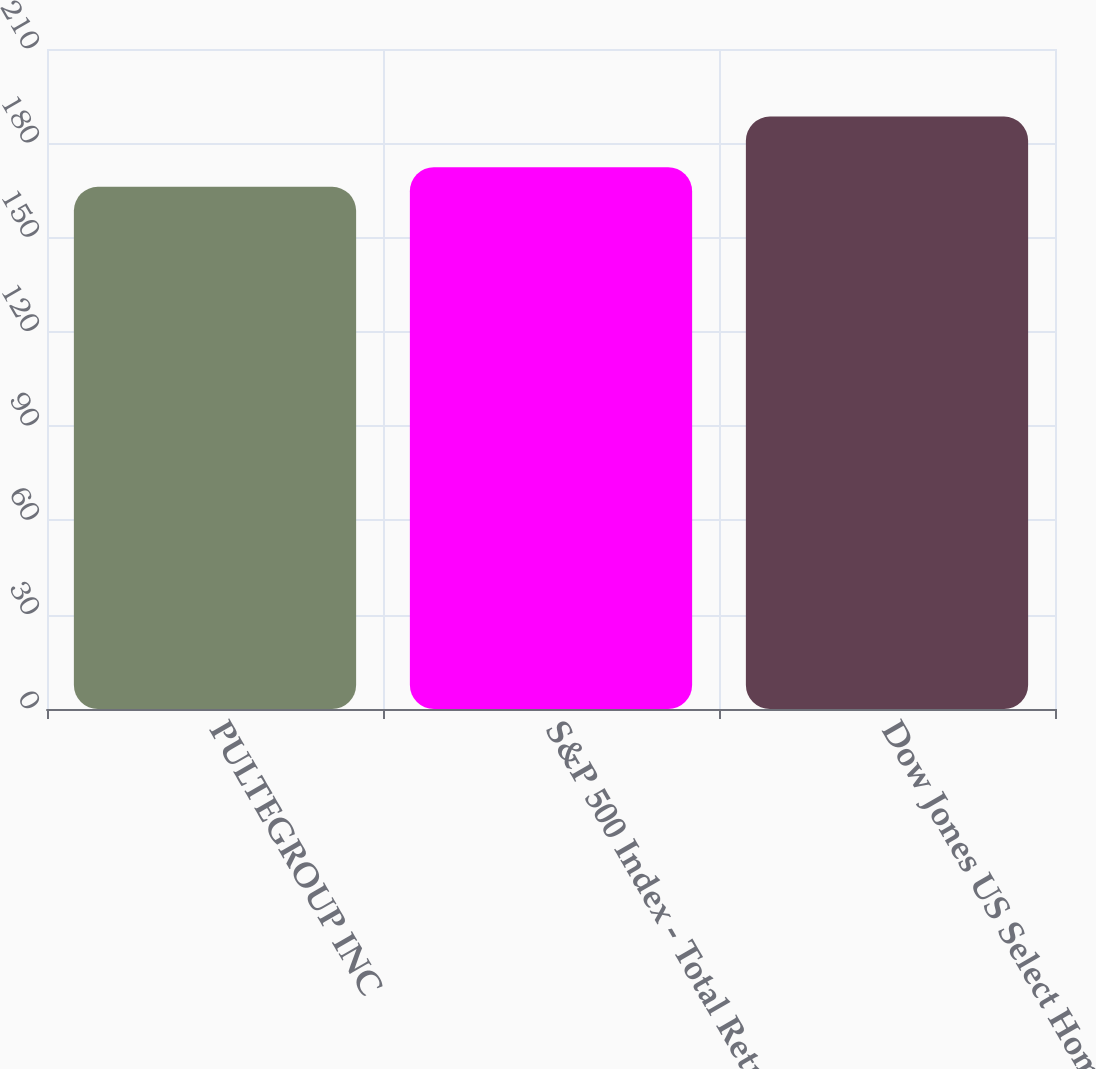<chart> <loc_0><loc_0><loc_500><loc_500><bar_chart><fcel>PULTEGROUP INC<fcel>S&P 500 Index - Total Return<fcel>Dow Jones US Select Home<nl><fcel>166.15<fcel>172.37<fcel>188.49<nl></chart> 